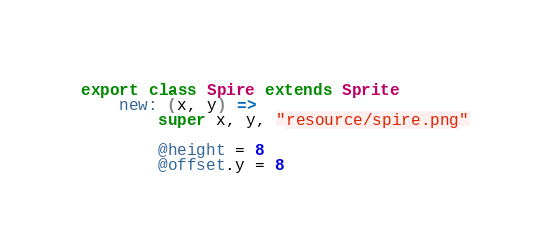<code> <loc_0><loc_0><loc_500><loc_500><_MoonScript_>export class Spire extends Sprite
	new: (x, y) =>
		super x, y, "resource/spire.png"

		@height = 8
		@offset.y = 8</code> 